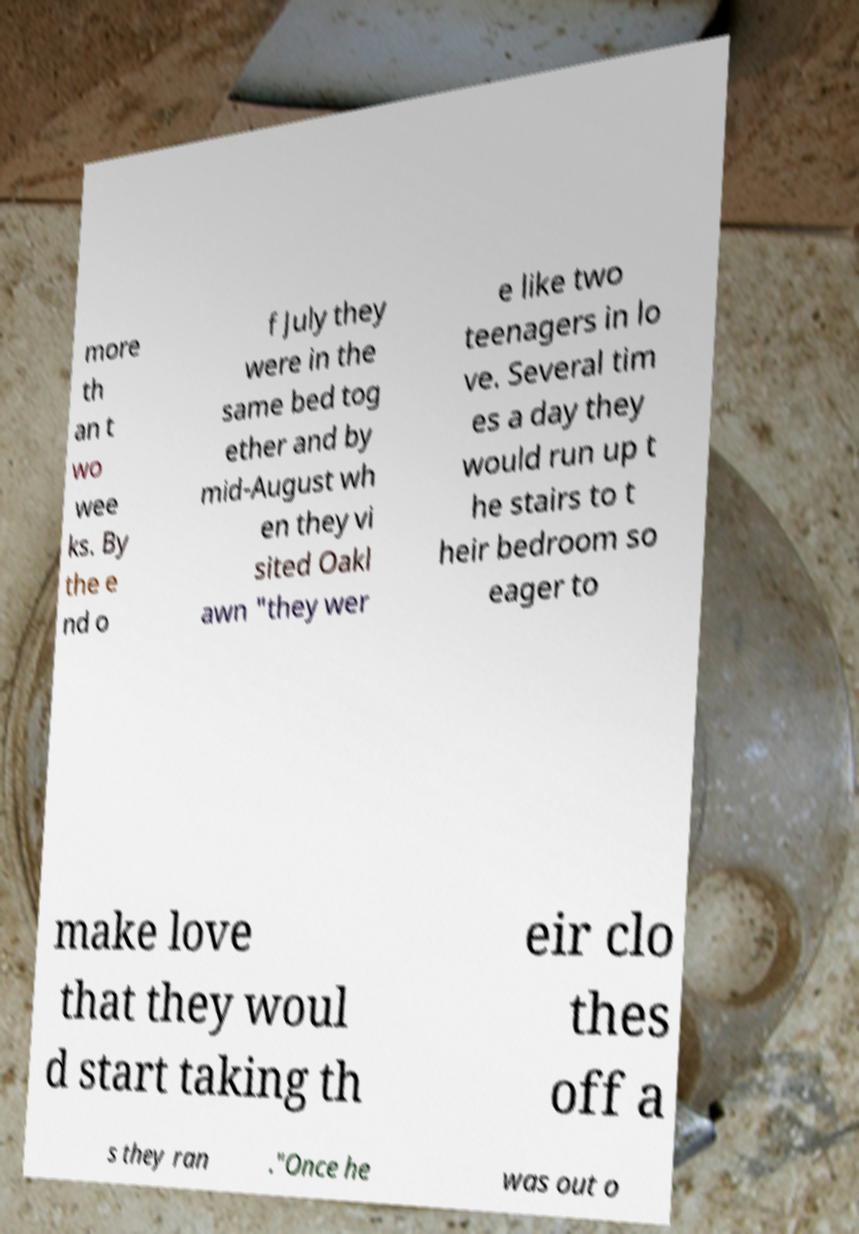Please read and relay the text visible in this image. What does it say? more th an t wo wee ks. By the e nd o f July they were in the same bed tog ether and by mid-August wh en they vi sited Oakl awn "they wer e like two teenagers in lo ve. Several tim es a day they would run up t he stairs to t heir bedroom so eager to make love that they woul d start taking th eir clo thes off a s they ran ."Once he was out o 